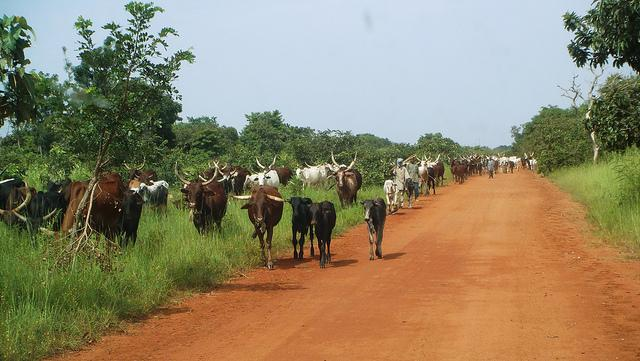What is on the dirt road? Please explain your reasoning. animals. The animals are on the road. 